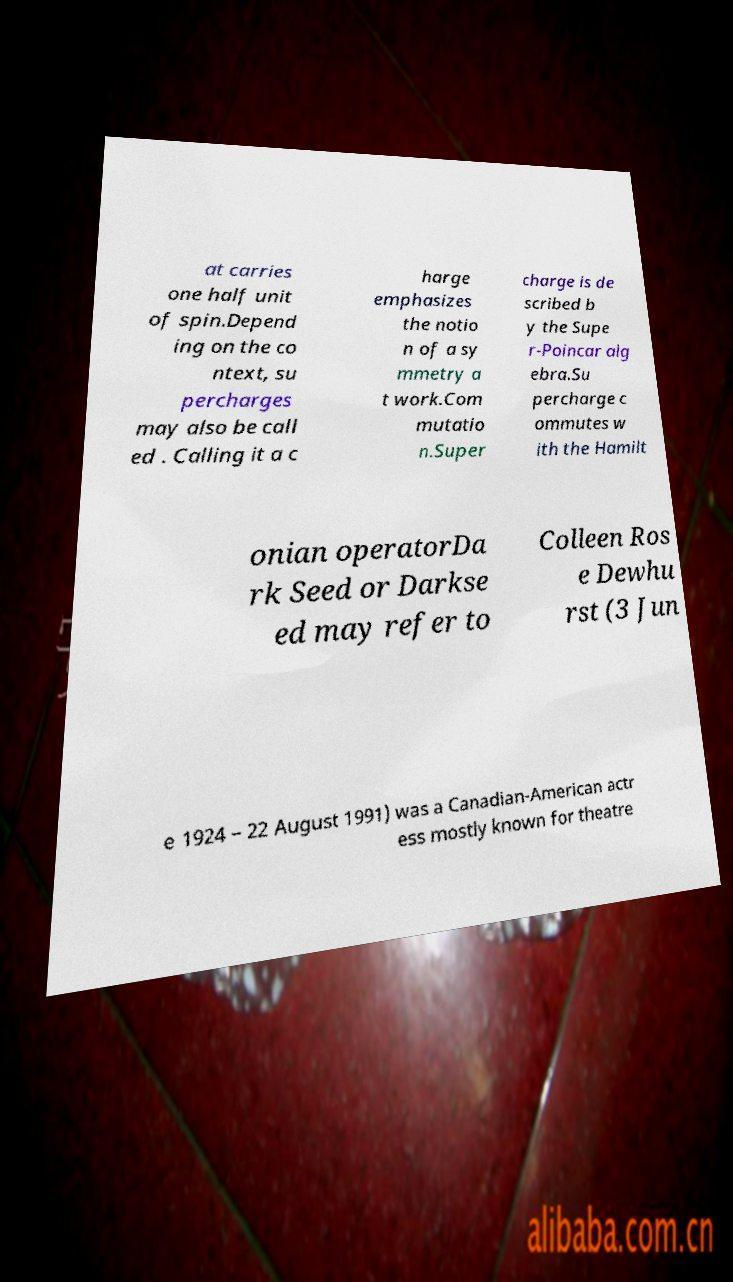Can you read and provide the text displayed in the image?This photo seems to have some interesting text. Can you extract and type it out for me? at carries one half unit of spin.Depend ing on the co ntext, su percharges may also be call ed . Calling it a c harge emphasizes the notio n of a sy mmetry a t work.Com mutatio n.Super charge is de scribed b y the Supe r-Poincar alg ebra.Su percharge c ommutes w ith the Hamilt onian operatorDa rk Seed or Darkse ed may refer to Colleen Ros e Dewhu rst (3 Jun e 1924 – 22 August 1991) was a Canadian-American actr ess mostly known for theatre 